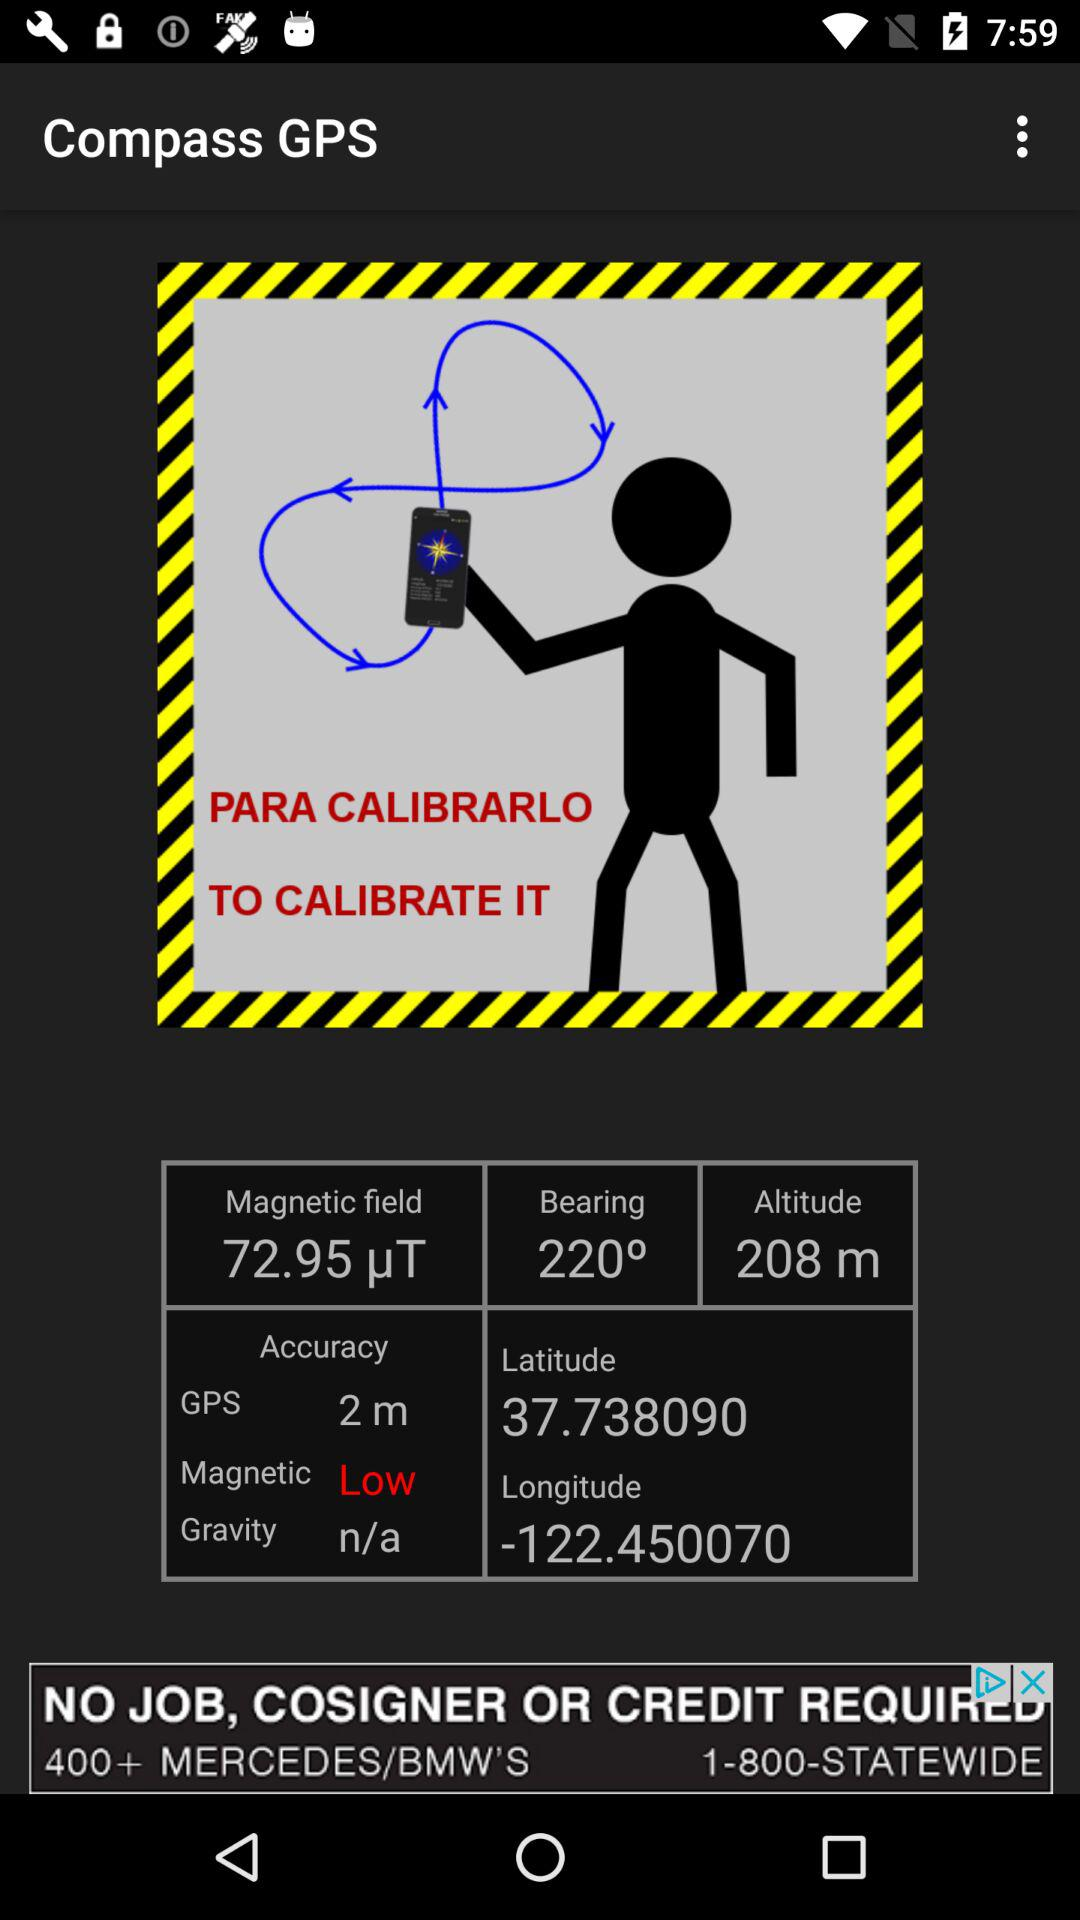What is the magnetic field? The magnetic field is 74.59 μT. 